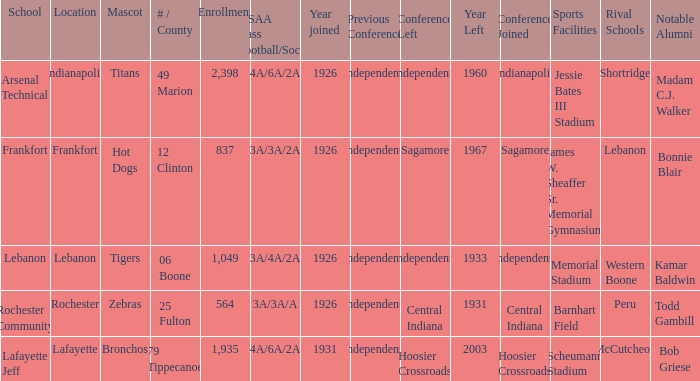What is the highest enrollment for rochester community school? 564.0. 